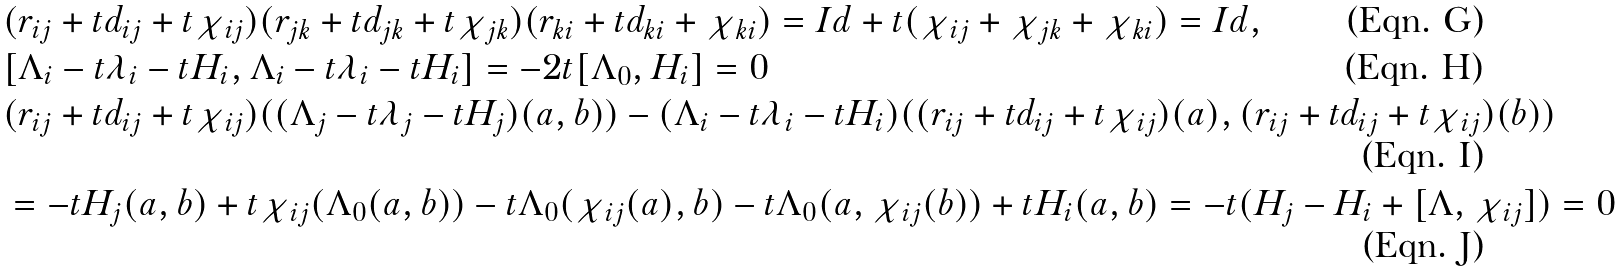<formula> <loc_0><loc_0><loc_500><loc_500>& ( r _ { i j } + t d _ { i j } + t \chi _ { i j } ) ( r _ { j k } + t d _ { j k } + t \chi _ { j k } ) ( r _ { k i } + t d _ { k i } + \chi _ { k i } ) = I d + t ( \chi _ { i j } + \chi _ { j k } + \chi _ { k i } ) = I d , \\ & [ \Lambda _ { i } - t \lambda _ { i } - t H _ { i } , \Lambda _ { i } - t \lambda _ { i } - t H _ { i } ] = - 2 t [ \Lambda _ { 0 } , H _ { i } ] = 0 \\ & ( r _ { i j } + t d _ { i j } + t \chi _ { i j } ) ( ( \Lambda _ { j } - t \lambda _ { j } - t H _ { j } ) ( a , b ) ) - ( \Lambda _ { i } - t \lambda _ { i } - t H _ { i } ) ( ( r _ { i j } + t d _ { i j } + t \chi _ { i j } ) ( a ) , ( r _ { i j } + t d _ { i j } + t \chi _ { i j } ) ( b ) ) \\ & = - t H _ { j } ( a , b ) + t \chi _ { i j } ( \Lambda _ { 0 } ( a , b ) ) - t \Lambda _ { 0 } ( \chi _ { i j } ( a ) , b ) - t \Lambda _ { 0 } ( a , \chi _ { i j } ( b ) ) + t H _ { i } ( a , b ) = - t ( H _ { j } - H _ { i } + [ \Lambda , \chi _ { i j } ] ) = 0</formula> 